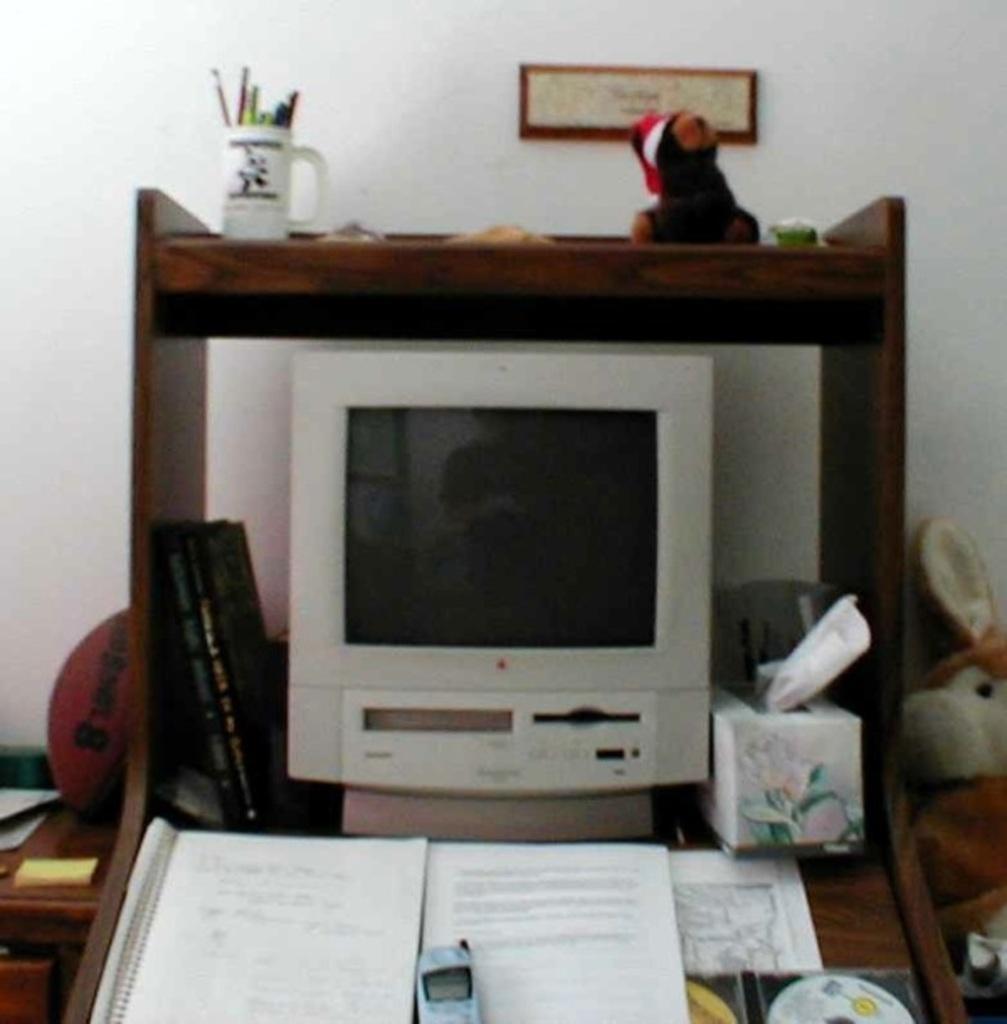How would you summarize this image in a sentence or two? Here we can see an electronic device which is kept on this wooden table. This books and a mobile phone are also kept on this wooden table. Here we can see a ball on the left side and a doll on the right side. 